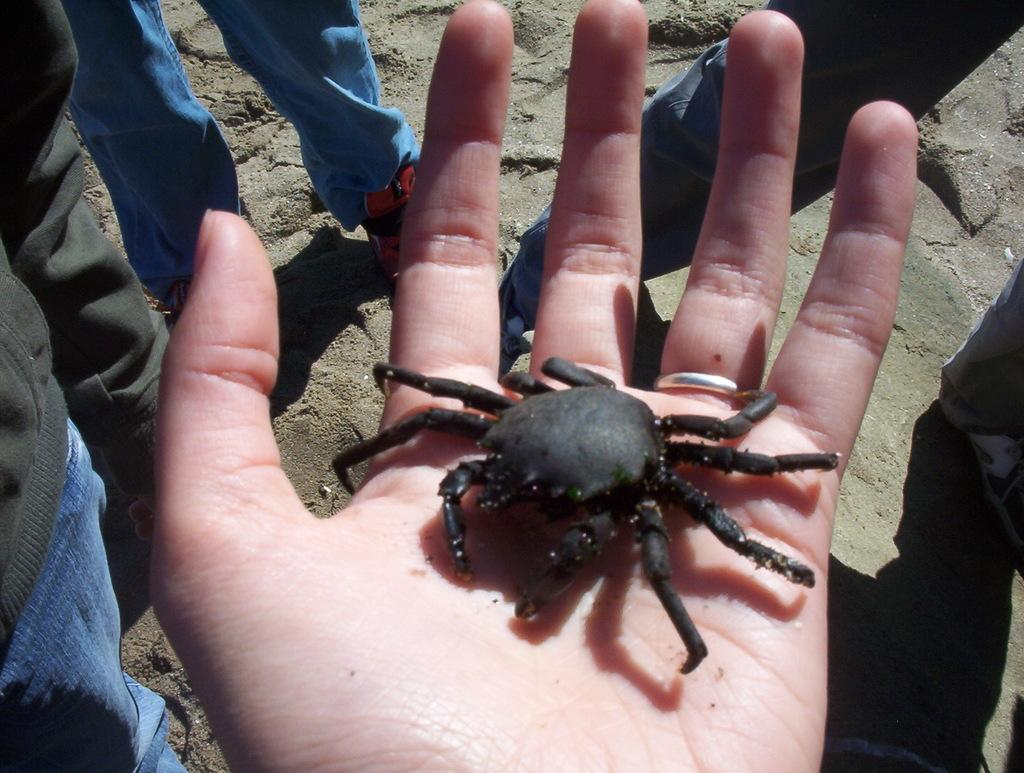What is the main subject of the picture? The main subject of the picture is a hand palm. What is on the hand palm? There is a crab on the hand palm. What is the color of the crab? The crab is black in color. What is the background of the hand palm and crab? There are people standing on a sand surface around the hand palm. What type of wall can be seen in the image? There is no wall present in the image; it features a hand palm with a crab on it and people standing on a sand surface in the background. 